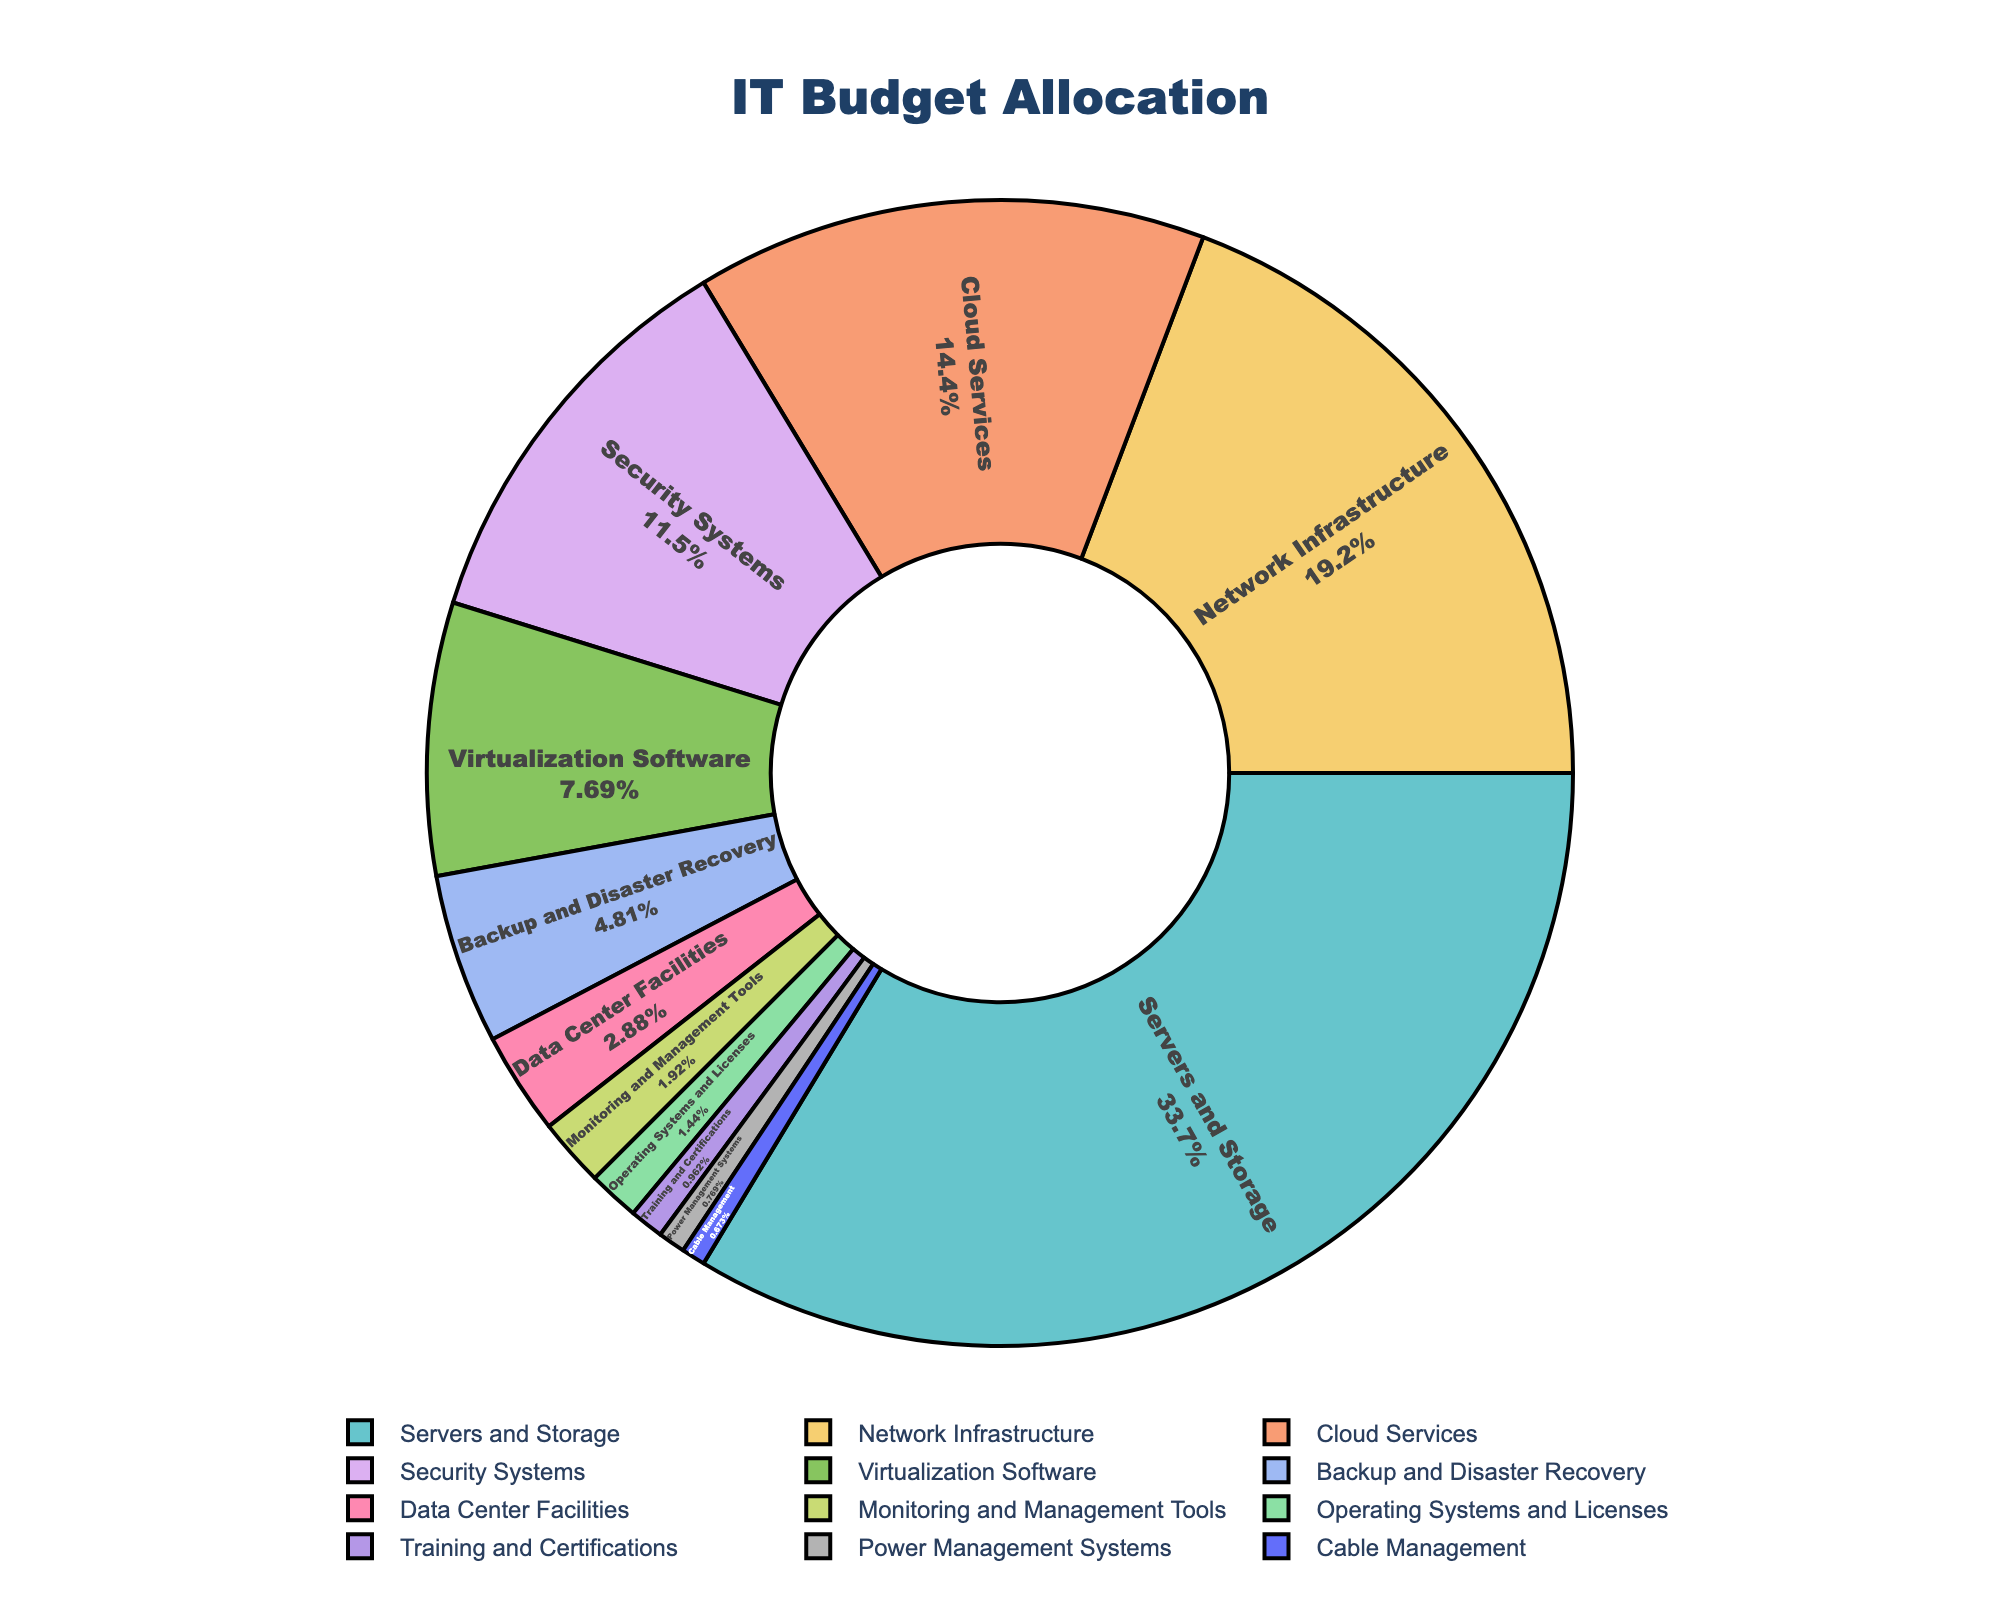What percentage of the IT budget is allocated to Security Systems and Virtualization Software combined? To find the combined allocation, add the percentages for Security Systems (12%) and Virtualization Software (8%). 12 + 8 = 20.
Answer: 20% Which component has the highest allocation in the IT budget? By examining the pie chart, the component with the largest segment is Servers and Storage, which accounts for 35% of the budget.
Answer: Servers and Storage Compare the allocation for Cloud Services to Backup and Disaster Recovery. Which one has a higher percentage and by how much? Cloud Services has 15% allocation while Backup and Disaster Recovery has 5%. To find the difference, subtract 5 from 15. 15 - 5 = 10.
Answer: Cloud Services by 10% What is the total percentage allocated to components with an allocation of less than 3%? Add the percentages for Monitoring and Management Tools (2%), Operating Systems and Licenses (1.5%), Training and Certifications (1%), Power Management Systems (0.8%), and Cable Management (0.7%). 2 + 1.5 + 1 + 0.8 + 0.7 = 6.
Answer: 6% Which components have allocations greater than 10%? The components with allocations greater than 10% are Servers and Storage (35%), Network Infrastructure (20%), and Security Systems (12%).
Answer: Servers and Storage, Network Infrastructure, Security Systems Which component receives the smallest allocation in the IT budget? The smallest segment in the pie chart is for Cable Management, with a 0.7% allocation.
Answer: Cable Management Is the allocation for Data Center Facilities higher than the combined allocation for Power Management Systems and Cable Management? By how much? The allocation for Data Center Facilities is 3%. For Power Management Systems and Cable Management, the combined allocation is 0.8 + 0.7 = 1.5%. To find the difference, subtract 1.5 from 3. 3 - 1.5 = 1.5.
Answer: Yes, by 1.5% Calculate the average percentage allocation for the top three components. The top three components are Servers and Storage (35%), Network Infrastructure (20%), and Cloud Services (15%). Add these and divide by 3. (35 + 20 + 15) / 3 = 70 / 3 ≈ 23.33.
Answer: 23.33% Compare the percentage allocations for Virtualization Software and Backup and Disaster Recovery. What is the ratio of Virtualization Software's allocation to Backup and Disaster Recovery's allocation? Virtualization Software is allocated 8%, and Backup and Disaster Recovery is allocated 5%. The ratio is 8:5.
Answer: 8:5 What is the difference in percentage allocation between Monitoring and Management Tools and Training and Certifications? Monitoring and Management Tools have a 2% allocation, while Training and Certifications have a 1% allocation. Subtract 1 from 2. 2 - 1 = 1.
Answer: 1% 